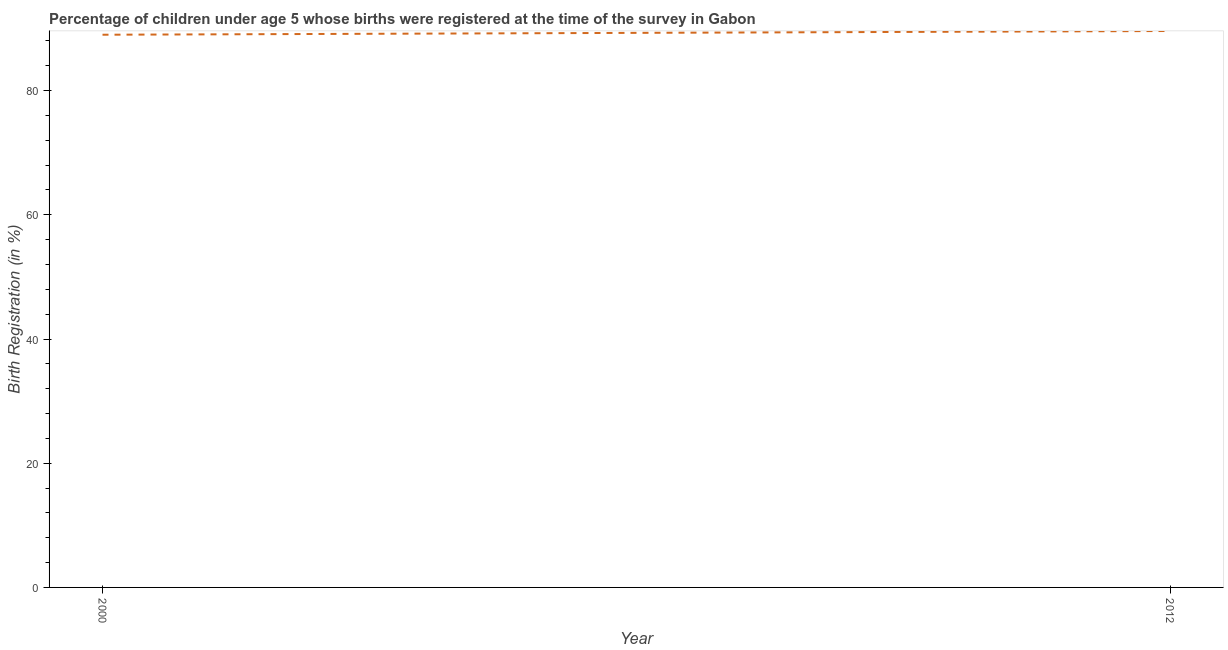What is the birth registration in 2000?
Provide a short and direct response. 89. Across all years, what is the maximum birth registration?
Make the answer very short. 89.6. Across all years, what is the minimum birth registration?
Offer a terse response. 89. In which year was the birth registration maximum?
Your response must be concise. 2012. In which year was the birth registration minimum?
Provide a succinct answer. 2000. What is the sum of the birth registration?
Provide a succinct answer. 178.6. What is the difference between the birth registration in 2000 and 2012?
Make the answer very short. -0.6. What is the average birth registration per year?
Offer a terse response. 89.3. What is the median birth registration?
Keep it short and to the point. 89.3. Do a majority of the years between 2000 and 2012 (inclusive) have birth registration greater than 16 %?
Your response must be concise. Yes. What is the ratio of the birth registration in 2000 to that in 2012?
Provide a succinct answer. 0.99. Does the birth registration monotonically increase over the years?
Provide a succinct answer. Yes. How many lines are there?
Your response must be concise. 1. What is the difference between two consecutive major ticks on the Y-axis?
Offer a terse response. 20. Are the values on the major ticks of Y-axis written in scientific E-notation?
Make the answer very short. No. What is the title of the graph?
Make the answer very short. Percentage of children under age 5 whose births were registered at the time of the survey in Gabon. What is the label or title of the Y-axis?
Make the answer very short. Birth Registration (in %). What is the Birth Registration (in %) of 2000?
Provide a succinct answer. 89. What is the Birth Registration (in %) of 2012?
Ensure brevity in your answer.  89.6. What is the ratio of the Birth Registration (in %) in 2000 to that in 2012?
Keep it short and to the point. 0.99. 